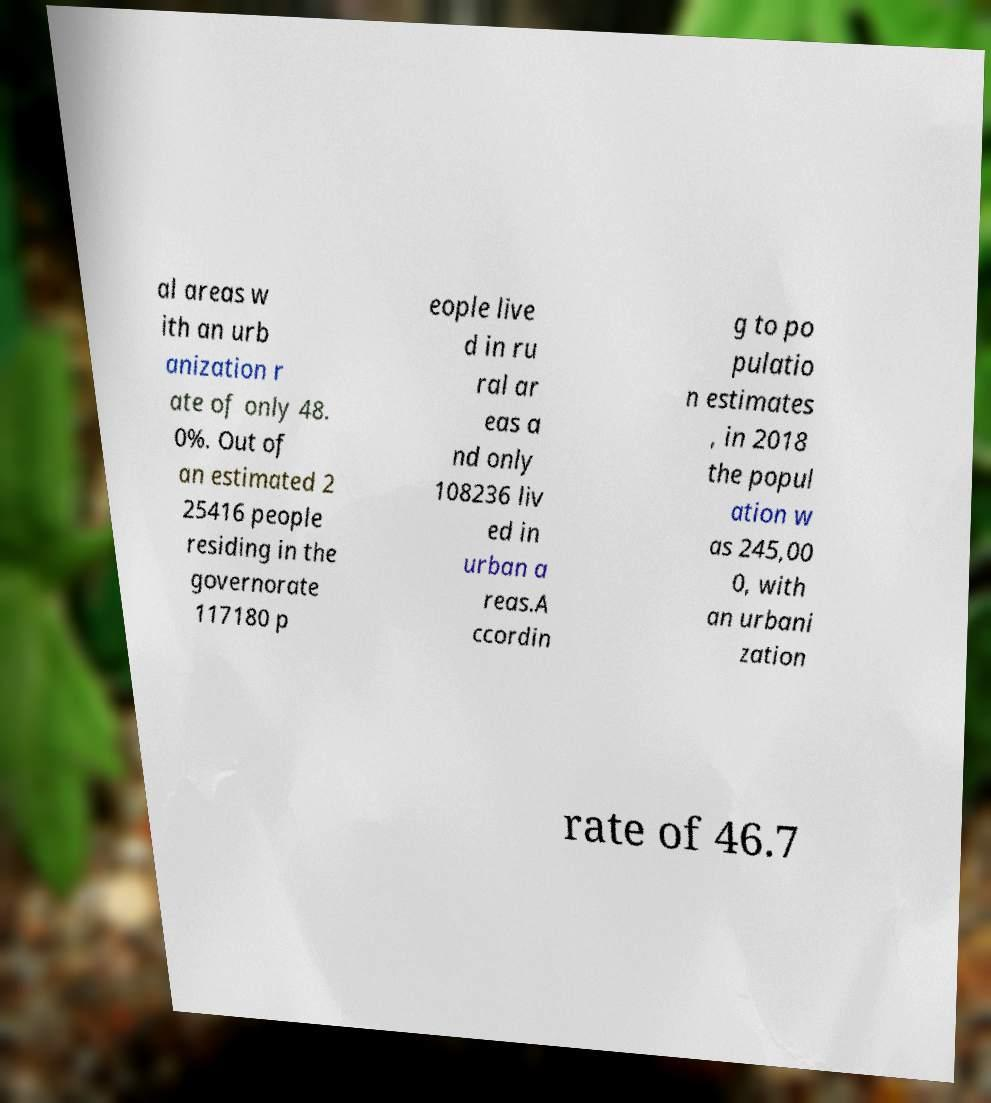Could you assist in decoding the text presented in this image and type it out clearly? al areas w ith an urb anization r ate of only 48. 0%. Out of an estimated 2 25416 people residing in the governorate 117180 p eople live d in ru ral ar eas a nd only 108236 liv ed in urban a reas.A ccordin g to po pulatio n estimates , in 2018 the popul ation w as 245,00 0, with an urbani zation rate of 46.7 